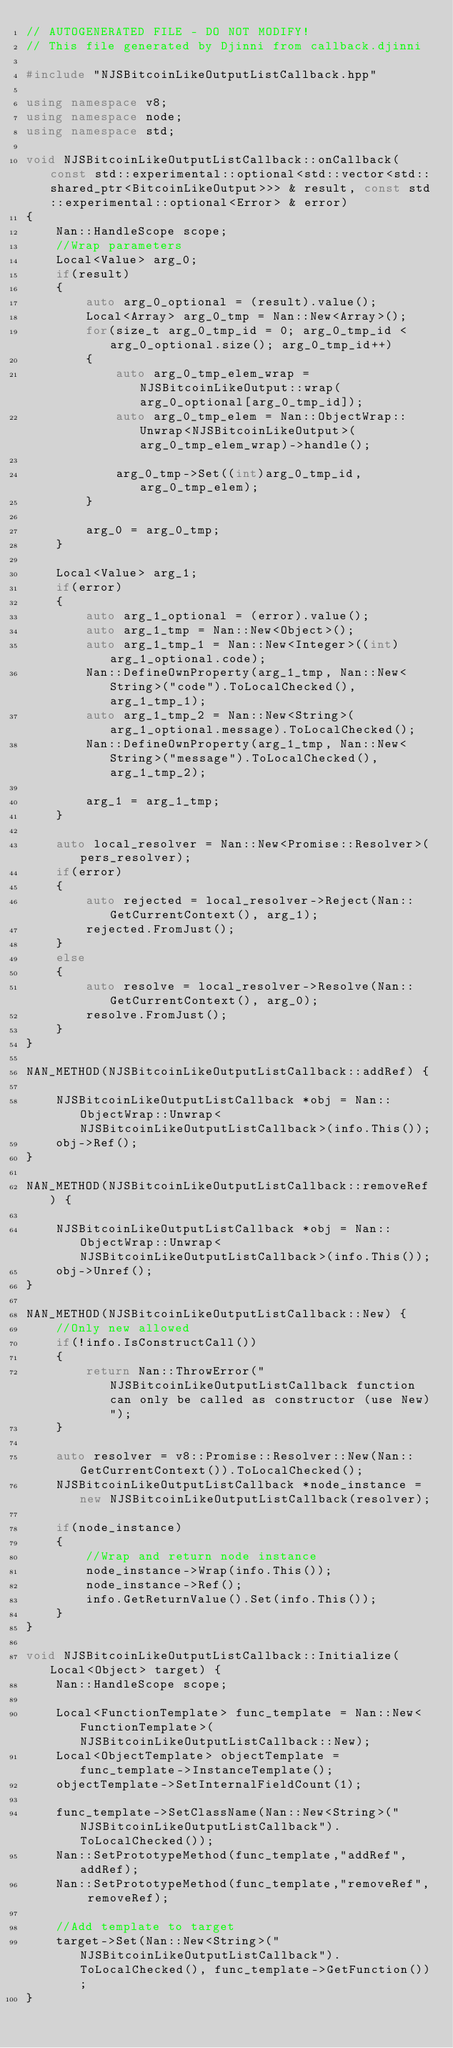Convert code to text. <code><loc_0><loc_0><loc_500><loc_500><_C++_>// AUTOGENERATED FILE - DO NOT MODIFY!
// This file generated by Djinni from callback.djinni

#include "NJSBitcoinLikeOutputListCallback.hpp"

using namespace v8;
using namespace node;
using namespace std;

void NJSBitcoinLikeOutputListCallback::onCallback(const std::experimental::optional<std::vector<std::shared_ptr<BitcoinLikeOutput>>> & result, const std::experimental::optional<Error> & error)
{
    Nan::HandleScope scope;
    //Wrap parameters
    Local<Value> arg_0;
    if(result)
    {
        auto arg_0_optional = (result).value();
        Local<Array> arg_0_tmp = Nan::New<Array>();
        for(size_t arg_0_tmp_id = 0; arg_0_tmp_id < arg_0_optional.size(); arg_0_tmp_id++)
        {
            auto arg_0_tmp_elem_wrap = NJSBitcoinLikeOutput::wrap(arg_0_optional[arg_0_tmp_id]);
            auto arg_0_tmp_elem = Nan::ObjectWrap::Unwrap<NJSBitcoinLikeOutput>(arg_0_tmp_elem_wrap)->handle();

            arg_0_tmp->Set((int)arg_0_tmp_id,arg_0_tmp_elem);
        }

        arg_0 = arg_0_tmp;
    }

    Local<Value> arg_1;
    if(error)
    {
        auto arg_1_optional = (error).value();
        auto arg_1_tmp = Nan::New<Object>();
        auto arg_1_tmp_1 = Nan::New<Integer>((int)arg_1_optional.code);
        Nan::DefineOwnProperty(arg_1_tmp, Nan::New<String>("code").ToLocalChecked(), arg_1_tmp_1);
        auto arg_1_tmp_2 = Nan::New<String>(arg_1_optional.message).ToLocalChecked();
        Nan::DefineOwnProperty(arg_1_tmp, Nan::New<String>("message").ToLocalChecked(), arg_1_tmp_2);

        arg_1 = arg_1_tmp;
    }

    auto local_resolver = Nan::New<Promise::Resolver>(pers_resolver);
    if(error)
    {
        auto rejected = local_resolver->Reject(Nan::GetCurrentContext(), arg_1);
        rejected.FromJust();
    }
    else
    {
        auto resolve = local_resolver->Resolve(Nan::GetCurrentContext(), arg_0);
        resolve.FromJust();
    }
}

NAN_METHOD(NJSBitcoinLikeOutputListCallback::addRef) {

    NJSBitcoinLikeOutputListCallback *obj = Nan::ObjectWrap::Unwrap<NJSBitcoinLikeOutputListCallback>(info.This());
    obj->Ref();
}

NAN_METHOD(NJSBitcoinLikeOutputListCallback::removeRef) {

    NJSBitcoinLikeOutputListCallback *obj = Nan::ObjectWrap::Unwrap<NJSBitcoinLikeOutputListCallback>(info.This());
    obj->Unref();
}

NAN_METHOD(NJSBitcoinLikeOutputListCallback::New) {
    //Only new allowed
    if(!info.IsConstructCall())
    {
        return Nan::ThrowError("NJSBitcoinLikeOutputListCallback function can only be called as constructor (use New)");
    }

    auto resolver = v8::Promise::Resolver::New(Nan::GetCurrentContext()).ToLocalChecked();
    NJSBitcoinLikeOutputListCallback *node_instance = new NJSBitcoinLikeOutputListCallback(resolver);

    if(node_instance)
    {
        //Wrap and return node instance
        node_instance->Wrap(info.This());
        node_instance->Ref();
        info.GetReturnValue().Set(info.This());
    }
}

void NJSBitcoinLikeOutputListCallback::Initialize(Local<Object> target) {
    Nan::HandleScope scope;

    Local<FunctionTemplate> func_template = Nan::New<FunctionTemplate>(NJSBitcoinLikeOutputListCallback::New);
    Local<ObjectTemplate> objectTemplate = func_template->InstanceTemplate();
    objectTemplate->SetInternalFieldCount(1);

    func_template->SetClassName(Nan::New<String>("NJSBitcoinLikeOutputListCallback").ToLocalChecked());
    Nan::SetPrototypeMethod(func_template,"addRef", addRef);
    Nan::SetPrototypeMethod(func_template,"removeRef", removeRef);

    //Add template to target
    target->Set(Nan::New<String>("NJSBitcoinLikeOutputListCallback").ToLocalChecked(), func_template->GetFunction());
}
</code> 